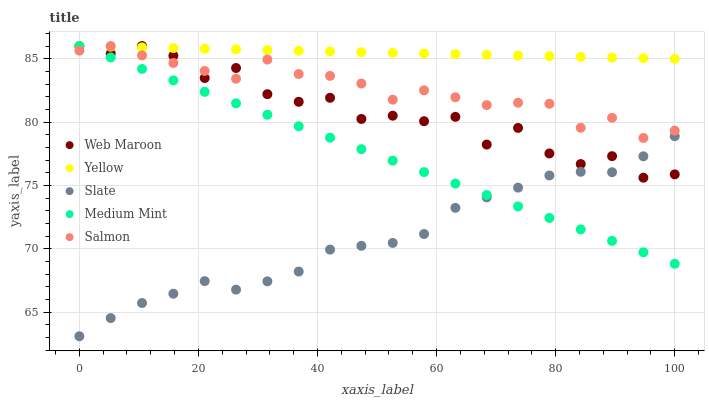Does Slate have the minimum area under the curve?
Answer yes or no. Yes. Does Yellow have the maximum area under the curve?
Answer yes or no. Yes. Does Salmon have the minimum area under the curve?
Answer yes or no. No. Does Salmon have the maximum area under the curve?
Answer yes or no. No. Is Medium Mint the smoothest?
Answer yes or no. Yes. Is Web Maroon the roughest?
Answer yes or no. Yes. Is Salmon the smoothest?
Answer yes or no. No. Is Salmon the roughest?
Answer yes or no. No. Does Slate have the lowest value?
Answer yes or no. Yes. Does Salmon have the lowest value?
Answer yes or no. No. Does Yellow have the highest value?
Answer yes or no. Yes. Does Slate have the highest value?
Answer yes or no. No. Is Slate less than Salmon?
Answer yes or no. Yes. Is Yellow greater than Slate?
Answer yes or no. Yes. Does Web Maroon intersect Slate?
Answer yes or no. Yes. Is Web Maroon less than Slate?
Answer yes or no. No. Is Web Maroon greater than Slate?
Answer yes or no. No. Does Slate intersect Salmon?
Answer yes or no. No. 